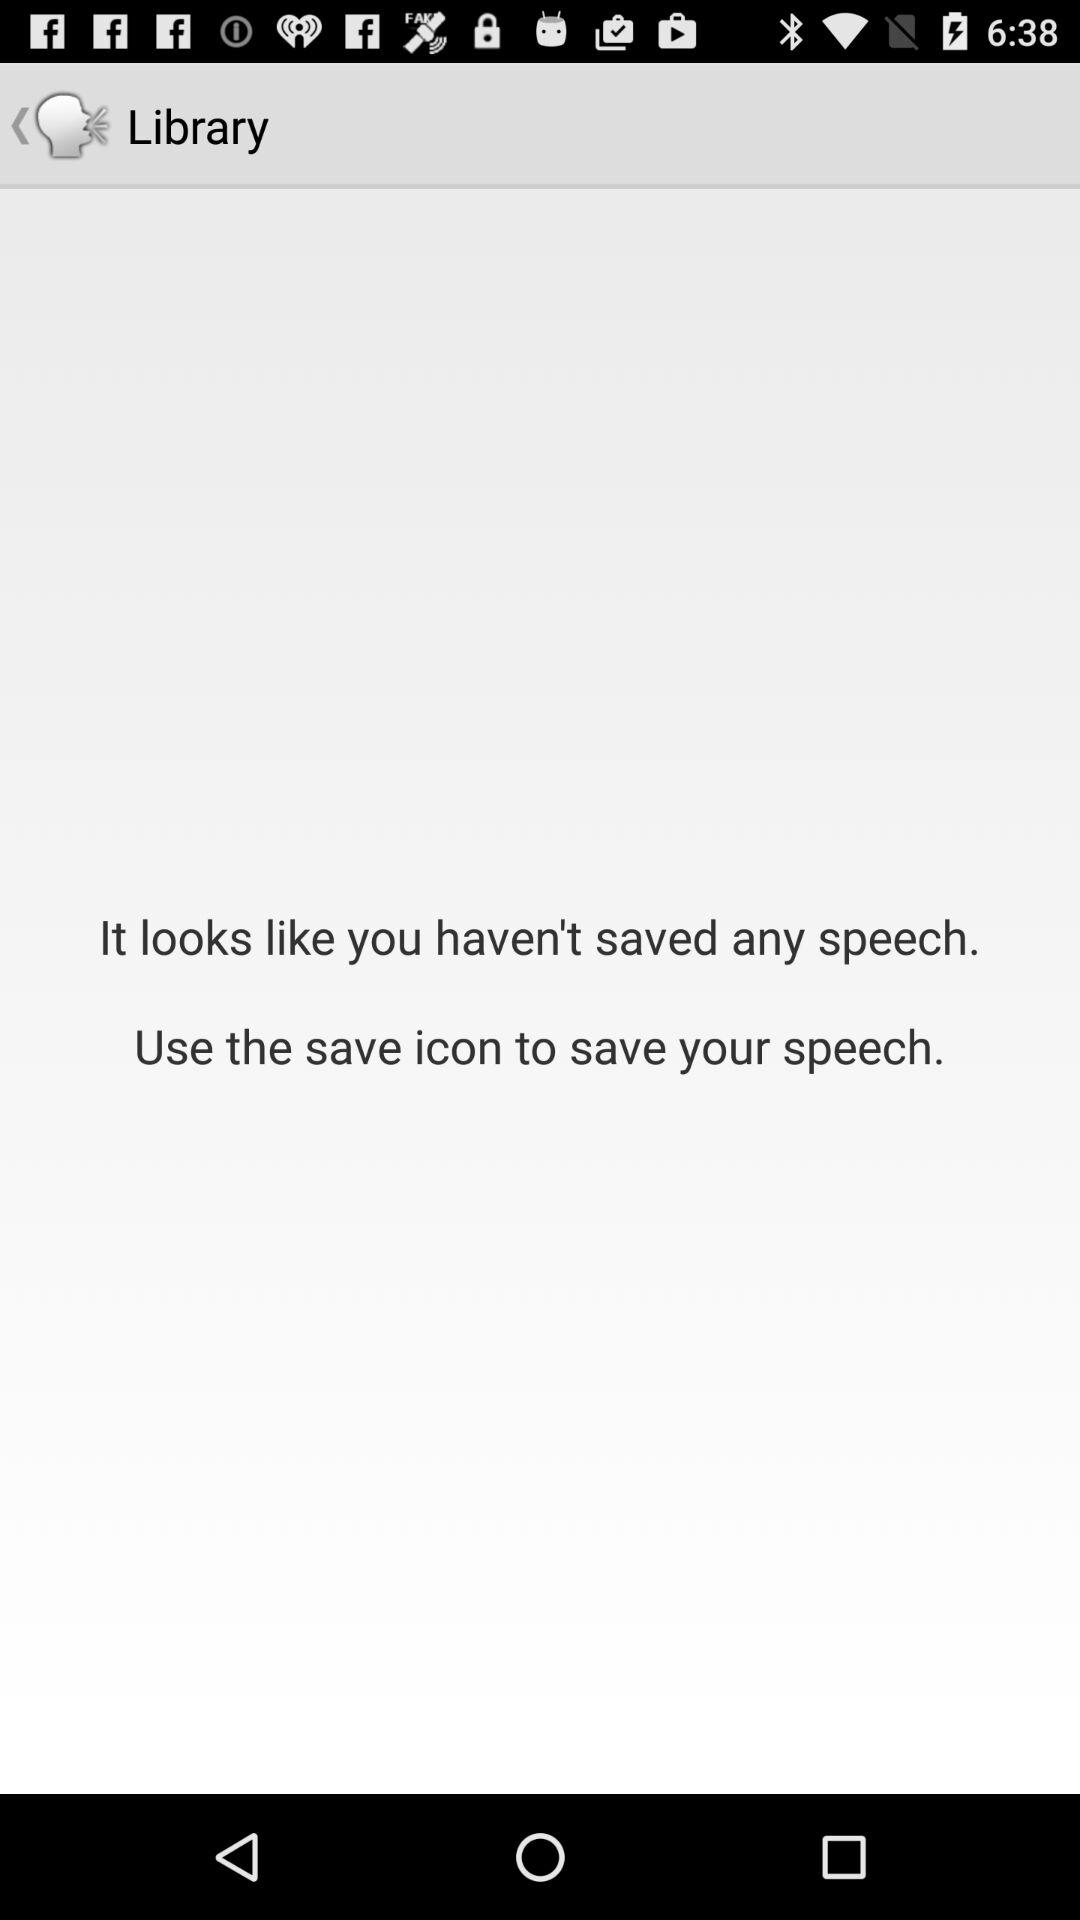What is the number of saved speeches in my library? You haven't saved any speeches in your library. 